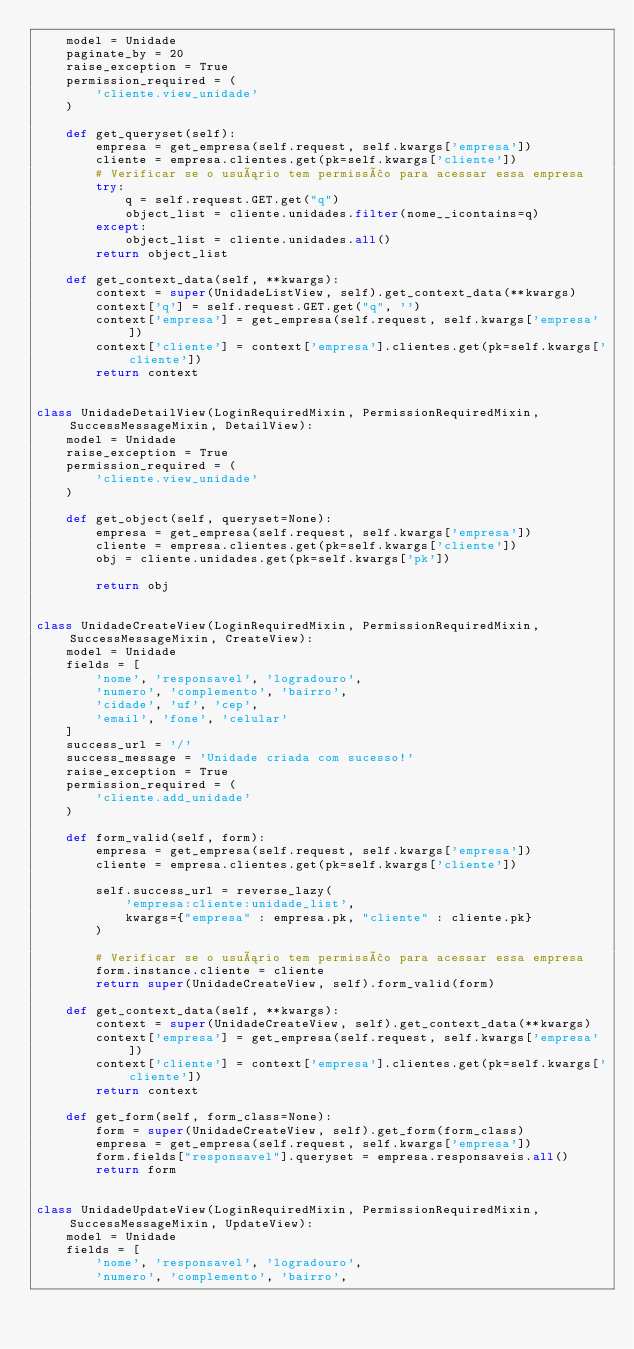<code> <loc_0><loc_0><loc_500><loc_500><_Python_>    model = Unidade
    paginate_by = 20
    raise_exception = True
    permission_required = (
        'cliente.view_unidade'
    )

    def get_queryset(self):
        empresa = get_empresa(self.request, self.kwargs['empresa'])
        cliente = empresa.clientes.get(pk=self.kwargs['cliente'])
        # Verificar se o usuário tem permissão para acessar essa empresa
        try:
            q = self.request.GET.get("q")
            object_list = cliente.unidades.filter(nome__icontains=q)
        except:
            object_list = cliente.unidades.all()
        return object_list

    def get_context_data(self, **kwargs):
        context = super(UnidadeListView, self).get_context_data(**kwargs)
        context['q'] = self.request.GET.get("q", '')
        context['empresa'] = get_empresa(self.request, self.kwargs['empresa'])
        context['cliente'] = context['empresa'].clientes.get(pk=self.kwargs['cliente'])
        return context


class UnidadeDetailView(LoginRequiredMixin, PermissionRequiredMixin, SuccessMessageMixin, DetailView):
    model = Unidade
    raise_exception = True
    permission_required = (
        'cliente.view_unidade'
    )

    def get_object(self, queryset=None):
        empresa = get_empresa(self.request, self.kwargs['empresa'])
        cliente = empresa.clientes.get(pk=self.kwargs['cliente'])
        obj = cliente.unidades.get(pk=self.kwargs['pk'])

        return obj


class UnidadeCreateView(LoginRequiredMixin, PermissionRequiredMixin, SuccessMessageMixin, CreateView):
    model = Unidade
    fields = [
        'nome', 'responsavel', 'logradouro',
        'numero', 'complemento', 'bairro', 
        'cidade', 'uf', 'cep',
        'email', 'fone', 'celular'
    ]
    success_url = '/'
    success_message = 'Unidade criada com sucesso!'
    raise_exception = True
    permission_required = (
        'cliente.add_unidade'
    )

    def form_valid(self, form):
        empresa = get_empresa(self.request, self.kwargs['empresa'])
        cliente = empresa.clientes.get(pk=self.kwargs['cliente'])

        self.success_url = reverse_lazy(
            'empresa:cliente:unidade_list',
            kwargs={"empresa" : empresa.pk, "cliente" : cliente.pk}
        )
        
        # Verificar se o usuário tem permissão para acessar essa empresa
        form.instance.cliente = cliente
        return super(UnidadeCreateView, self).form_valid(form)

    def get_context_data(self, **kwargs):
        context = super(UnidadeCreateView, self).get_context_data(**kwargs)
        context['empresa'] = get_empresa(self.request, self.kwargs['empresa'])
        context['cliente'] = context['empresa'].clientes.get(pk=self.kwargs['cliente'])
        return context

    def get_form(self, form_class=None):    
        form = super(UnidadeCreateView, self).get_form(form_class)
        empresa = get_empresa(self.request, self.kwargs['empresa'])
        form.fields["responsavel"].queryset = empresa.responsaveis.all()
        return form


class UnidadeUpdateView(LoginRequiredMixin, PermissionRequiredMixin, SuccessMessageMixin, UpdateView):
    model = Unidade
    fields = [
        'nome', 'responsavel', 'logradouro',
        'numero', 'complemento', 'bairro', </code> 